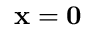Convert formula to latex. <formula><loc_0><loc_0><loc_500><loc_500>{ x } = { 0 }</formula> 